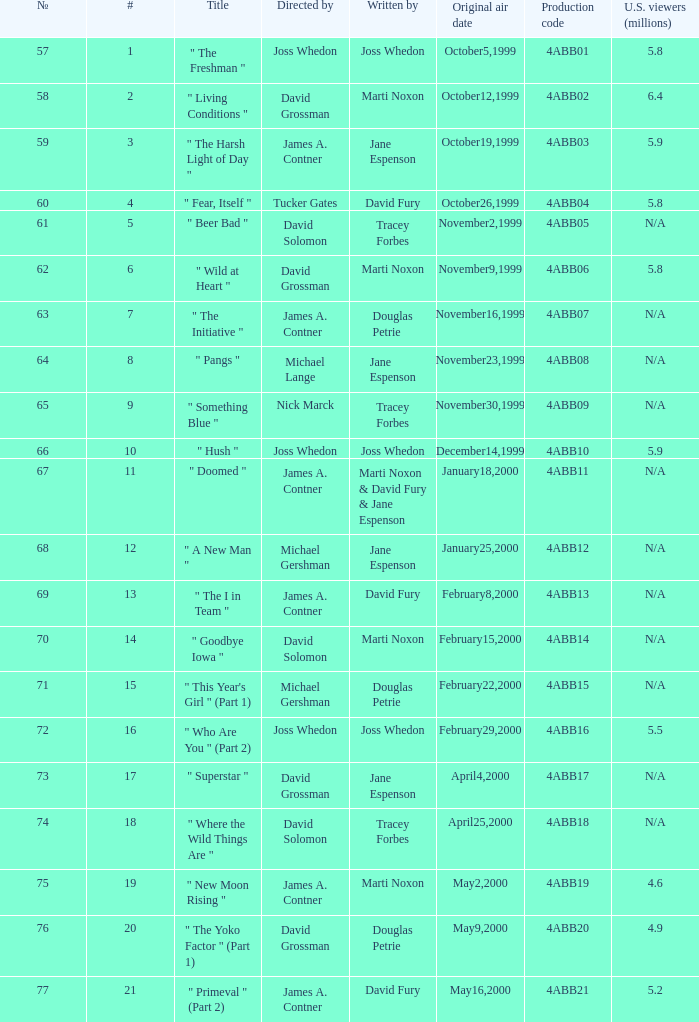What is the heading of episode no. 65? " Something Blue ". 